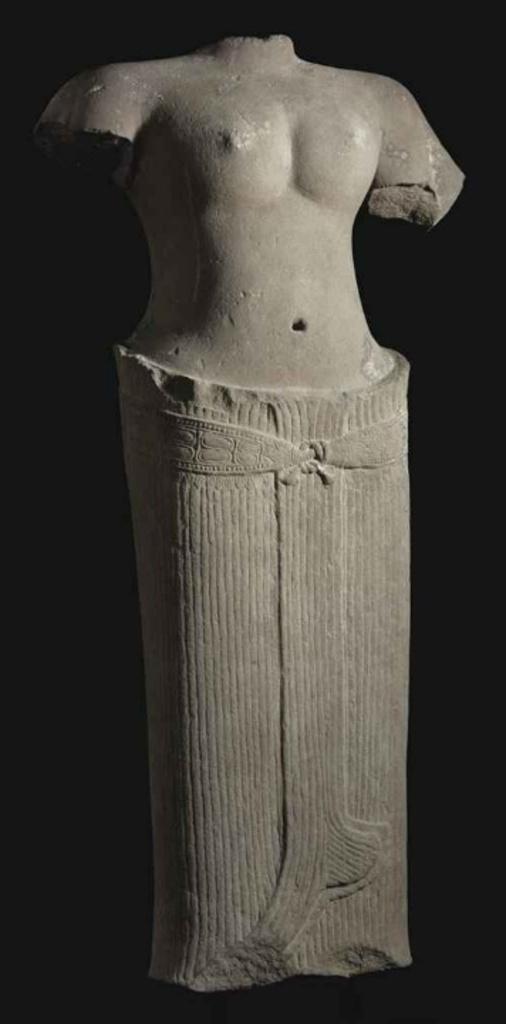Describe this image in one or two sentences. In this image we can see a statue and dark background. 